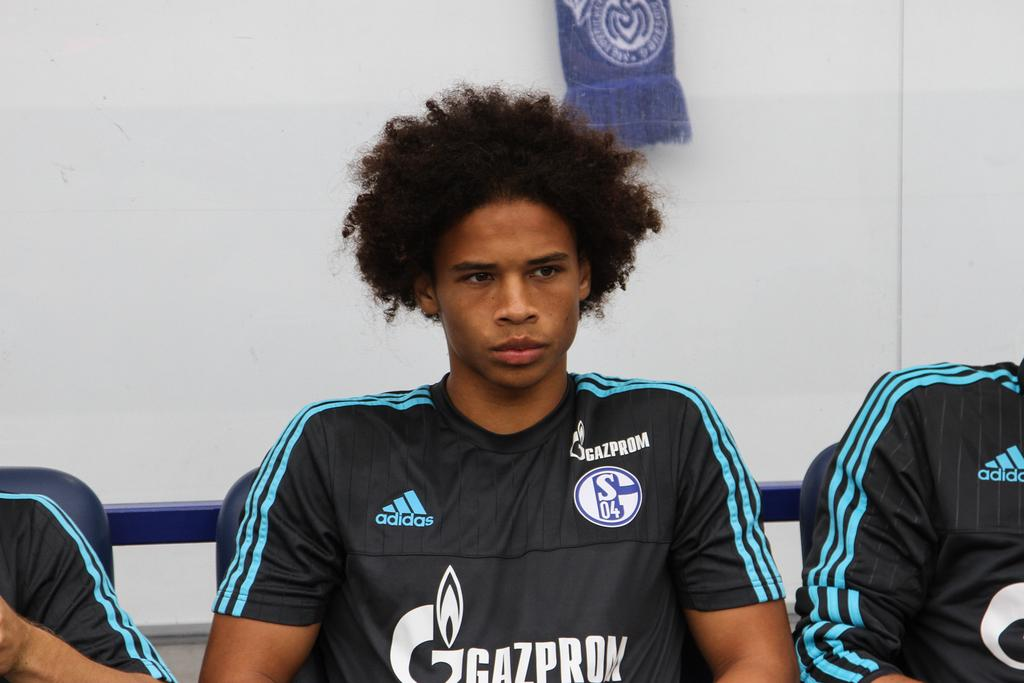<image>
Give a short and clear explanation of the subsequent image. a player sits with the word gazprom on his shirt 